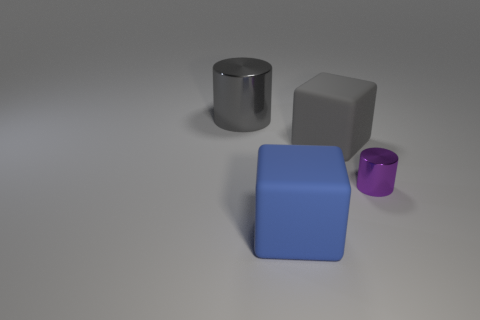Are there any other things that are the same size as the purple metal cylinder?
Offer a very short reply. No. How many yellow objects are either matte blocks or cylinders?
Provide a succinct answer. 0. What is the material of the big gray object that is the same shape as the blue thing?
Your answer should be very brief. Rubber. Are there the same number of big gray shiny objects that are on the left side of the large metallic thing and large purple rubber cubes?
Offer a terse response. Yes. What is the size of the object that is behind the large blue rubber block and in front of the gray matte block?
Your answer should be compact. Small. Are there any other things of the same color as the large metallic object?
Offer a very short reply. Yes. How big is the shiny object that is right of the object that is to the left of the blue rubber object?
Your response must be concise. Small. The thing that is to the right of the big blue rubber object and in front of the large gray cube is what color?
Keep it short and to the point. Purple. How many other things are the same size as the purple metal cylinder?
Provide a short and direct response. 0. Do the purple cylinder and the metallic object that is left of the tiny shiny object have the same size?
Your answer should be very brief. No. 